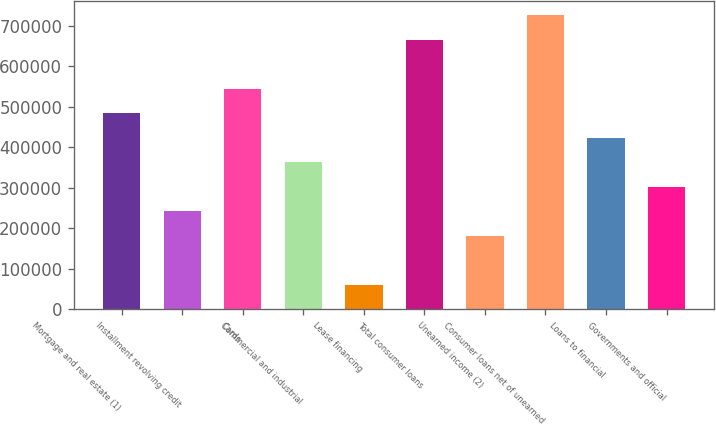Convert chart to OTSL. <chart><loc_0><loc_0><loc_500><loc_500><bar_chart><fcel>Mortgage and real estate (1)<fcel>Installment revolving credit<fcel>Cards<fcel>Commercial and industrial<fcel>Lease financing<fcel>Total consumer loans<fcel>Unearned income (2)<fcel>Consumer loans net of unearned<fcel>Loans to financial<fcel>Governments and official<nl><fcel>483993<fcel>241998<fcel>544492<fcel>362995<fcel>60500.9<fcel>665490<fcel>181499<fcel>725989<fcel>423494<fcel>302497<nl></chart> 